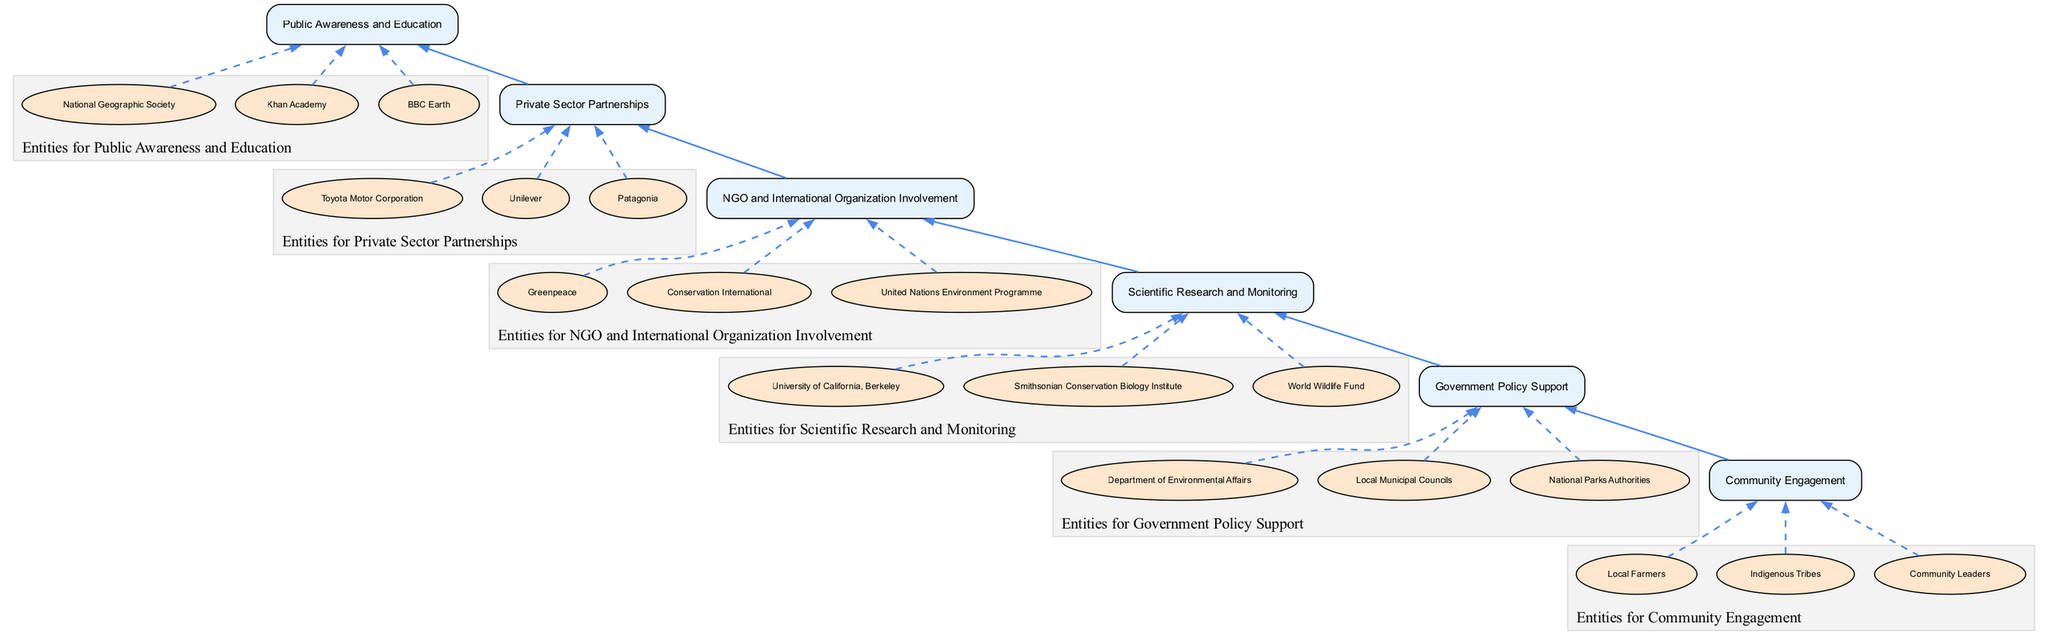What is the top element in the diagram? The top element can be found by looking at the flow from the bottom to the top, identifying that the last element listed is "Public Awareness and Education," which is at the top position in the flow chart.
Answer: Public Awareness and Education How many total entities are represented in the diagram? By counting each listed entity under the respective elements, we identify there are 18 entities in total. Each of the 6 elements has a different number of entities listed: 3 (Community Engagement) + 3 (Government Policy Support) + 3 (Scientific Research and Monitoring) + 3 (NGO and International Organization Involvement) + 3 (Private Sector Partnerships) + 3 (Public Awareness and Education) = 18.
Answer: 18 What is the function of "Scientific Research and Monitoring"? The function of "Scientific Research and Monitoring" is described in the diagram. It indicates that research institutions and universities conduct biodiversity assessments and monitor ecosystems to provide data necessary for conservation efforts. Thus, the role is primarily focused on assessments and monitoring.
Answer: Research assessments and monitoring Which element comes immediately before "NGO and International Organization Involvement"? To answer this question, we analyze the flow from bottom to top and identify the elements. The element that precedes "NGO and International Organization Involvement" in this upward flow is "Scientific Research and Monitoring."
Answer: Scientific Research and Monitoring Which entity belongs to the "Community Engagement" group? By cross-referencing the entities listed under "Community Engagement," we can confirm that "Indigenous Tribes" is one entity within this group, as it is specifically mentioned in the data associated with that element.
Answer: Indigenous Tribes Which element is connected to the "Private Sector Partnerships"? Reviewing the flow of the diagram, "Private Sector Partnerships" has a direct upward connection to "Public Awareness and Education," indicating that there is a relationship between these two elements in the context of biodiversity hotspot conservation efforts.
Answer: Public Awareness and Education What is the role of "Government Policy Support" in conservation efforts? "Government Policy Support" is described as providing regulatory and financial assistance from national and local authorities, which is critical for the implementation and success of conservation plans. Thus, its role is primarily related to support through policies and funding.
Answer: Regulatory and financial support How many nodes are there in total, including elements and entities? The total number of nodes consists of 6 element nodes (one for each main element) and 12 entity nodes (two entities for each of the 6 elements, totaling 18 entities). Thus, there are 6 + 18 = 24 nodes in total.
Answer: 24 What is the main pathway from "Community Engagement" to "Public Awareness and Education"? The pathway extracts as follows: Starting at "Community Engagement," it connects upward to "Government Policy Support," then to "Scientific Research and Monitoring," followed by "NGO and International Organization Involvement," leading to "Private Sector Partnerships," and finally reaching "Public Awareness and Education." This path indicates the flow of stakeholder involvement in conservation activities.
Answer: Community Engagement -> Government Policy Support -> Scientific Research and Monitoring -> NGO and International Organization Involvement -> Private Sector Partnerships -> Public Awareness and Education 